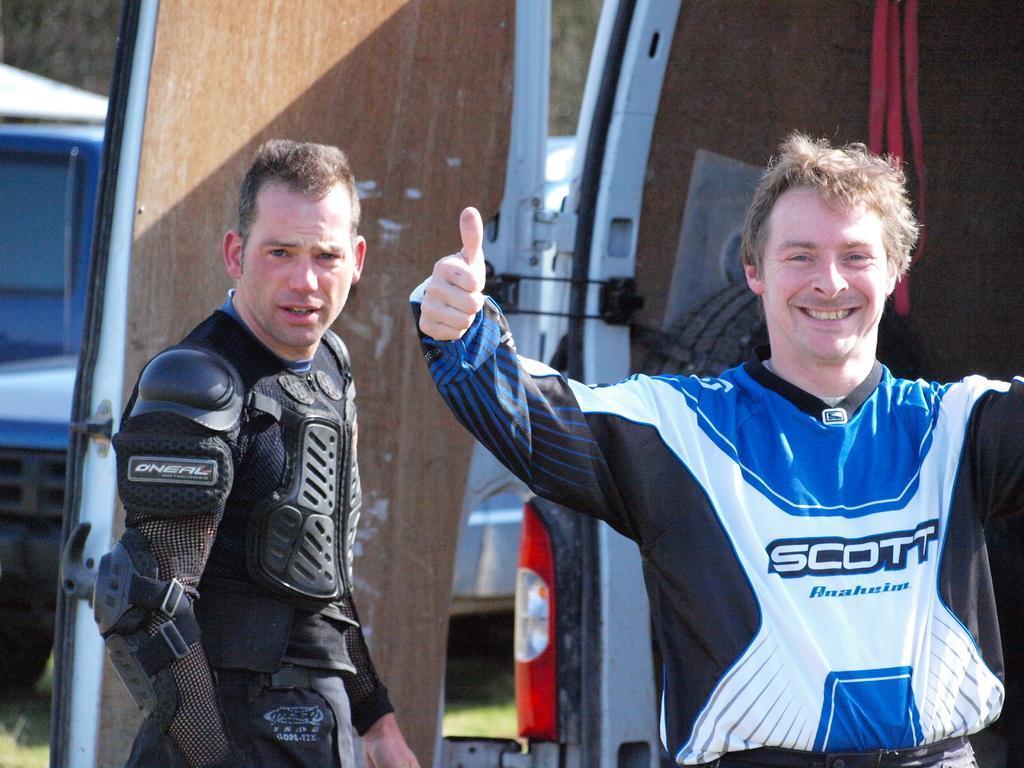Provide a one-sentence caption for the provided image. two men with sports clothes on, one says Scott. 